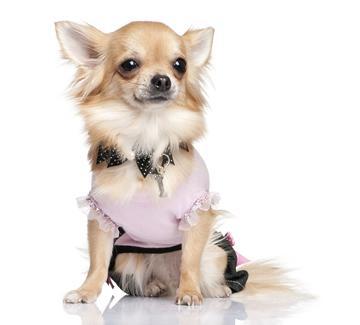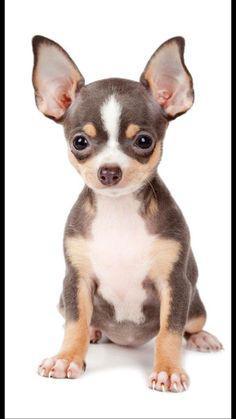The first image is the image on the left, the second image is the image on the right. Examine the images to the left and right. Is the description "The images show five dogs." accurate? Answer yes or no. No. The first image is the image on the left, the second image is the image on the right. Examine the images to the left and right. Is the description "There are at least five chihuahuas." accurate? Answer yes or no. No. 